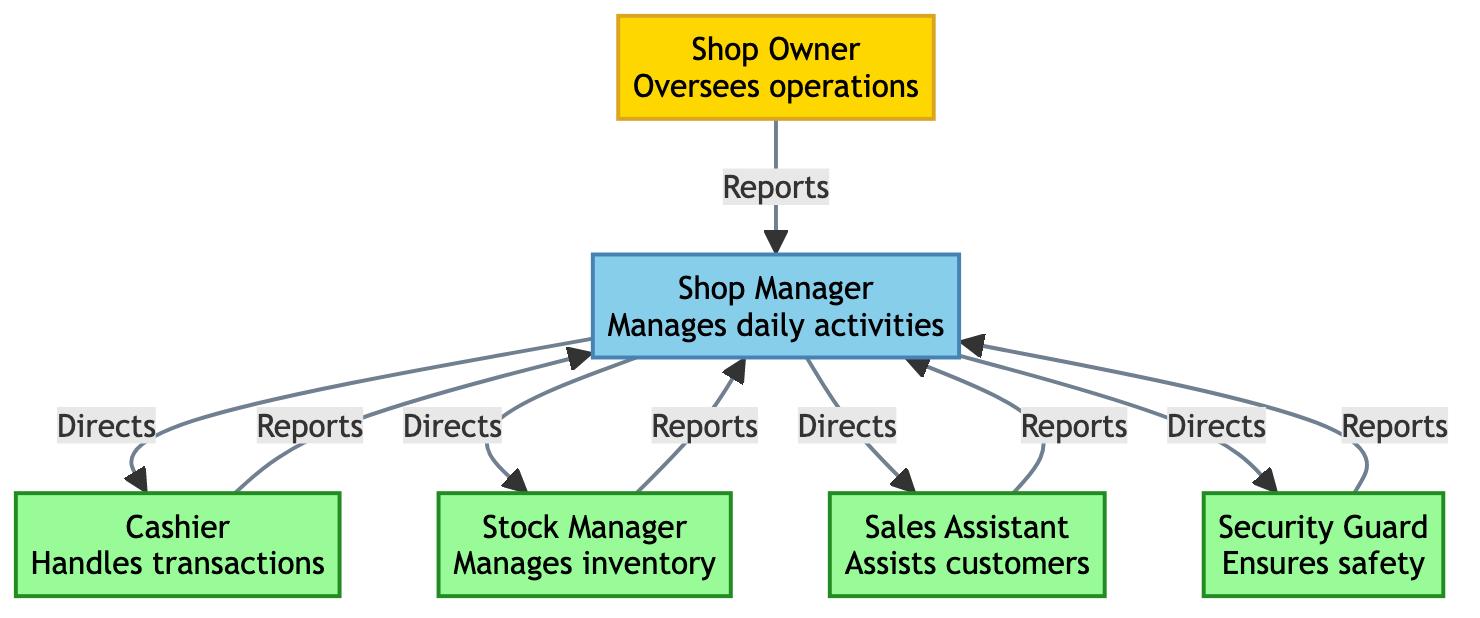What is the role of the Cashier? The role of the Cashier is to handle customer transactions, as described in the node label for Cashier.
Answer: Handles customer transactions How many employees report to the Manager? The diagram shows four distinct employees (Cashier, Stock Manager, Sales Assistant, Security) reporting to the Manager. This is counted from the edges connected to the Manager.
Answer: Four Who oversees the operations of the shop? The Shop Owner is identified as the one who oversees operations in the description of the Owner node.
Answer: Shop Owner What is the relationship between the Manager and the Cashier? The relationship is characterized by the edge labeled "Directs," indicating that the Manager directs the Cashier's activities.
Answer: Directs Which employee manages inventory? The Stock Manager is the designated employee responsible for managing inventory, as stated in the Stock Manager node.
Answer: Stock Manager How many nodes are present in the diagram? There are six nodes representing different roles in the shop: Owner, Manager, Cashier, Stock Manager, Sales Assistant, and Security. This total is determined by counting the nodes listed.
Answer: Six Who does the Security Guard report to? The Security Guard reports to the Manager, as indicated by the edge labeled "Reports" connecting Security to Manager.
Answer: Manager Which employee assists customers? The role of assisting customers belongs to the Sales Assistant, as noted in the Sales Assistant node's label.
Answer: Sales Assistant What type of communication does the Stock Manager have with the Manager? The communication is categorized as "Reports," based on the edge connecting Stock Manager to Manager.
Answer: Reports 